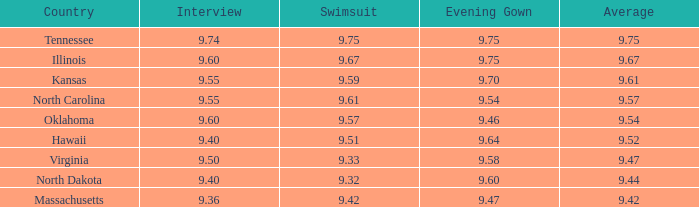What was the average for the country with the swimsuit score of 9.57? 9.54. 